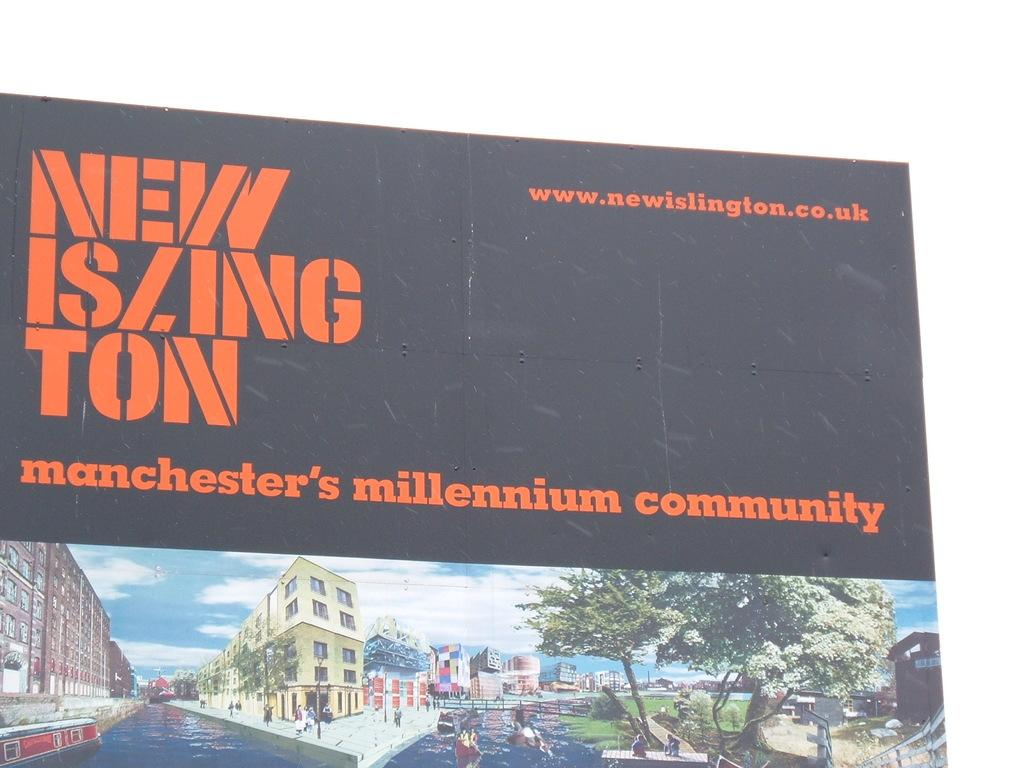<image>
Share a concise interpretation of the image provided. An advertisment for a millennium community shows drawings of streets and buildings. 